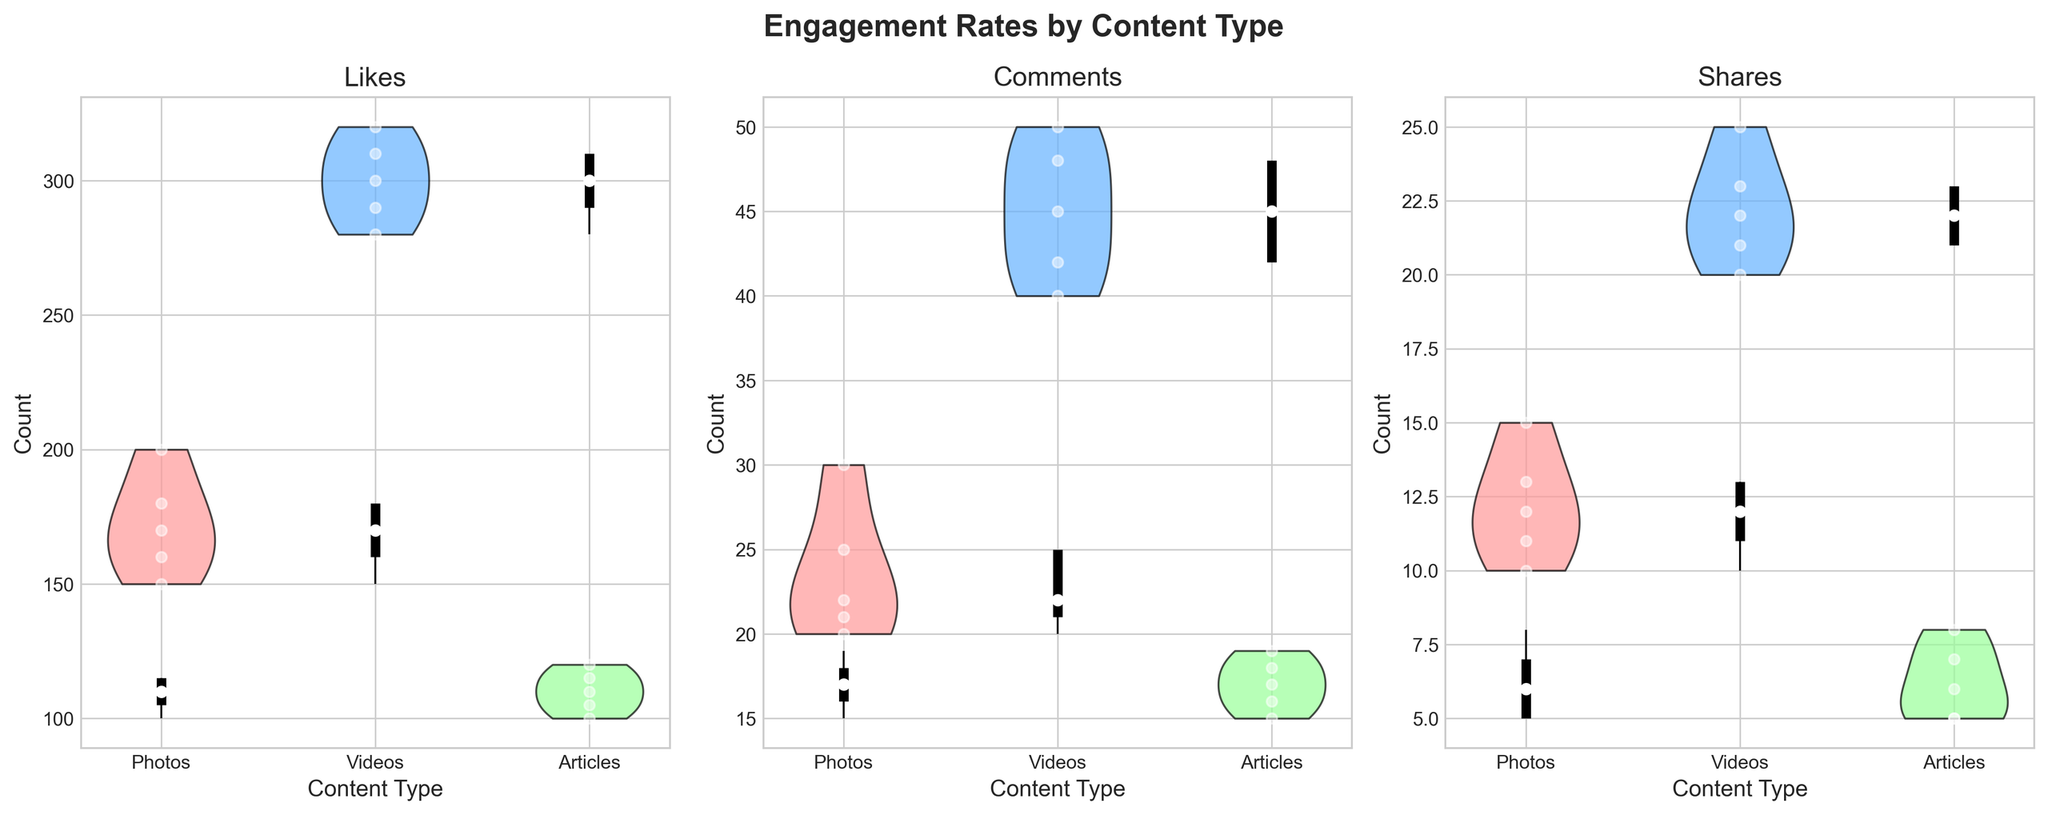Which content type has the highest median number of likes? The median value for likes is shown at the center of the violin plots. For Photos, Videos, and Articles, the median values are 170, 300, and 110 respectively. The highest median is for Videos.
Answer: Videos How do the quartile ranges of comments compare between Photos and Articles? The quartile ranges are the thick vertical lines in the violin plots. For Photos, the quartile range for comments is from about 21 to 25. For Articles, the quartile range is from about 16 to 18. The range for Photos is wider than for Articles.
Answer: Photos have a wider quartile range What is the interquartile range (IQR) for shares in Videos? The interquartile range (IQR) is the difference between the third (75th percentile) and first quartile (25th percentile). For Videos, the first quartile for shares is about 21, and the third quartile is about 25. Thus, the IQR is 25 - 21 = 4.
Answer: 4 Which content type has the smallest spread in shares? The spread in shares can be assessed through the overall length of the violin plot. Articles have the smallest spread (range) in shares compared to Photos and Videos.
Answer: Articles Compare the highest value of comments between Photos and Videos. The highest adjacent value (upper whisker) of comments is the highest point of the lines extending from the quartile box. For Photos, it is about 30, and for Videos, it is about 50. Thus, Videos have a higher value.
Answer: Videos Which content type has the least variation in likes? Least variation can be assessed by the width and overall height of the violin plot. Articles have the least variation in likes as their violin plot is the narrowest and shortest.
Answer: Articles How many more shares do Videos have at the median compared to Photos? The median for shares is shown by the central dot in the violin plot. For Videos, the median is about 22.5, and for Photos, it is about 11. So, Videos have 22.5 - 11 = 11.5 more shares at the median.
Answer: 11.5 Which content type shows the highest overall engagement rate in terms of comments? Overall engagement rate should consider both median and IQR. Videos have both the highest median and interquartile value range in comments.
Answer: Videos What is the upper whisker value of likes for Photos? The upper whisker value is the maximum value excluding outliers, represented by the top line extending from the quartile in the violin plot. For Photos, it is about 200.
Answer: 200 